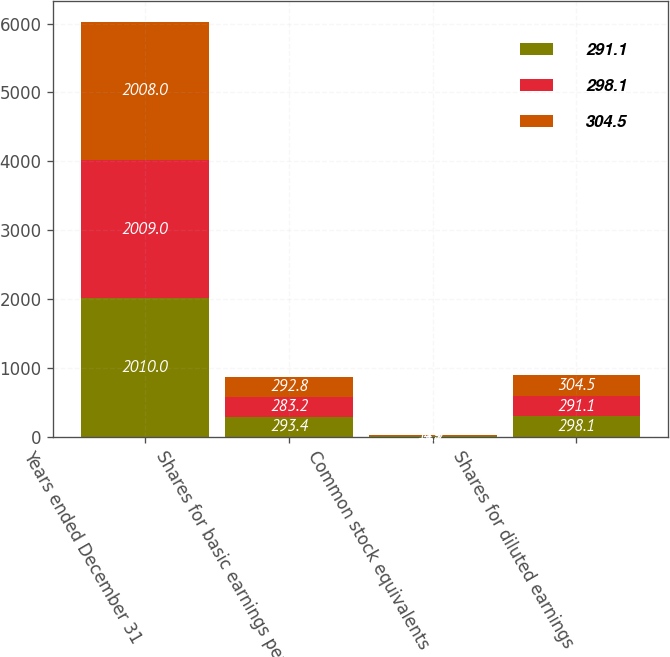Convert chart. <chart><loc_0><loc_0><loc_500><loc_500><stacked_bar_chart><ecel><fcel>Years ended December 31<fcel>Shares for basic earnings per<fcel>Common stock equivalents<fcel>Shares for diluted earnings<nl><fcel>291.1<fcel>2010<fcel>293.4<fcel>4.7<fcel>298.1<nl><fcel>298.1<fcel>2009<fcel>283.2<fcel>7.9<fcel>291.1<nl><fcel>304.5<fcel>2008<fcel>292.8<fcel>11.7<fcel>304.5<nl></chart> 